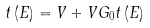Convert formula to latex. <formula><loc_0><loc_0><loc_500><loc_500>t \left ( E \right ) = V + V G _ { 0 } t \left ( E \right )</formula> 